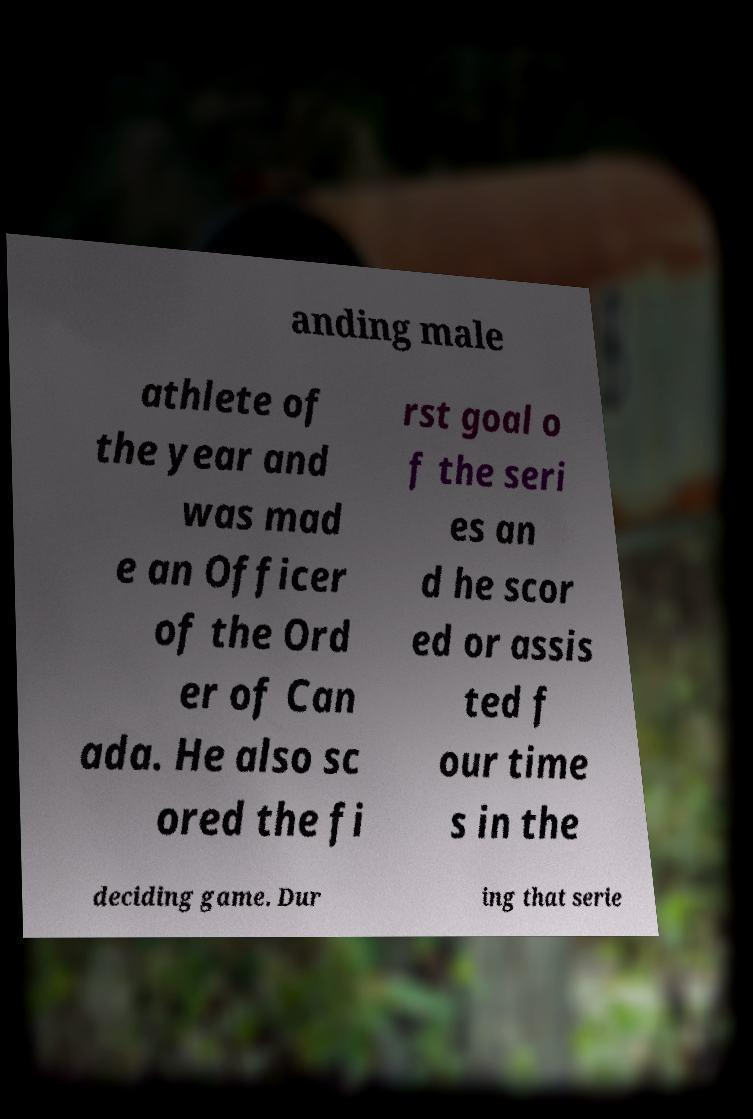Please read and relay the text visible in this image. What does it say? anding male athlete of the year and was mad e an Officer of the Ord er of Can ada. He also sc ored the fi rst goal o f the seri es an d he scor ed or assis ted f our time s in the deciding game. Dur ing that serie 